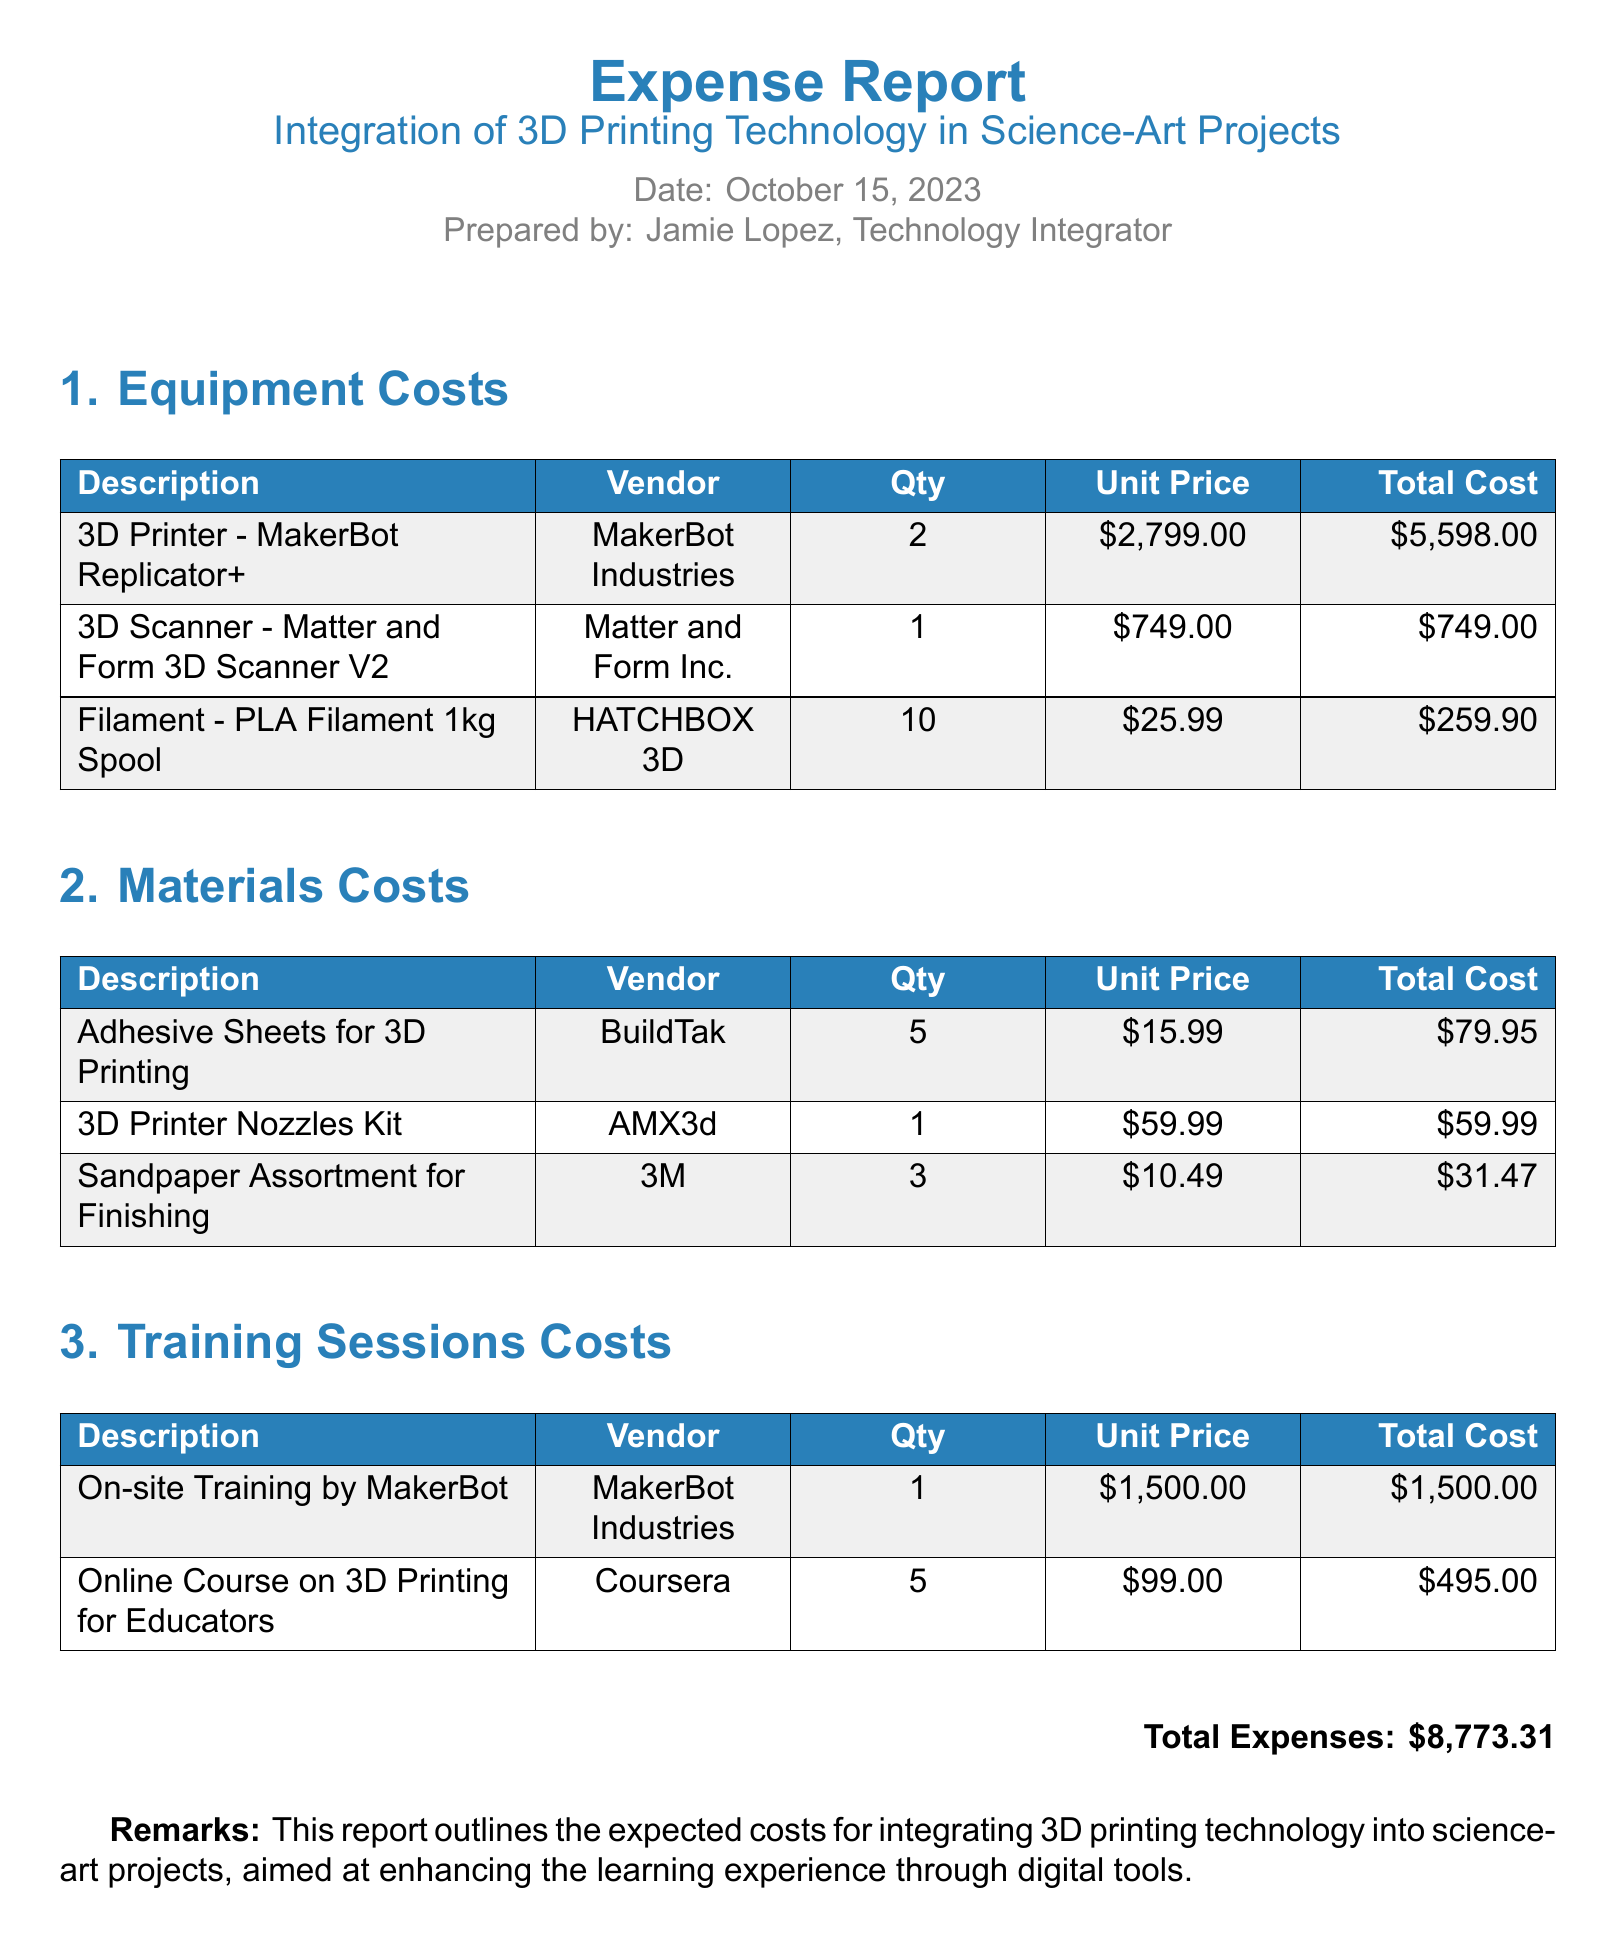What is the date of the report? The date of the report is specified in the document header.
Answer: October 15, 2023 Who prepared the report? The document states who prepared the report at the top.
Answer: Jamie Lopez How many 3D printers were purchased? The equipment costs section provides the quantity of 3D printers.
Answer: 2 What is the total cost for the adhesive sheets? The materials costs section lists the total cost for adhesive sheets.
Answer: $79.95 What is the total expenses amount? The total expenses line summarizes the overall costs listed in the report.
Answer: $8,773.31 How much was spent on training sessions? The training sessions costs section lists the total for that category.
Answer: $1,995.00 Which vendor sold the 3D scanner? The equipment costs section includes the vendor for the 3D scanner.
Answer: Matter and Form Inc How many online courses were included in the training sessions? The training sessions costs section indicates the quantity of online courses.
Answer: 5 What is the unit price of PLA filament? The materials costs section provides the unit price of PLA filament.
Answer: $25.99 